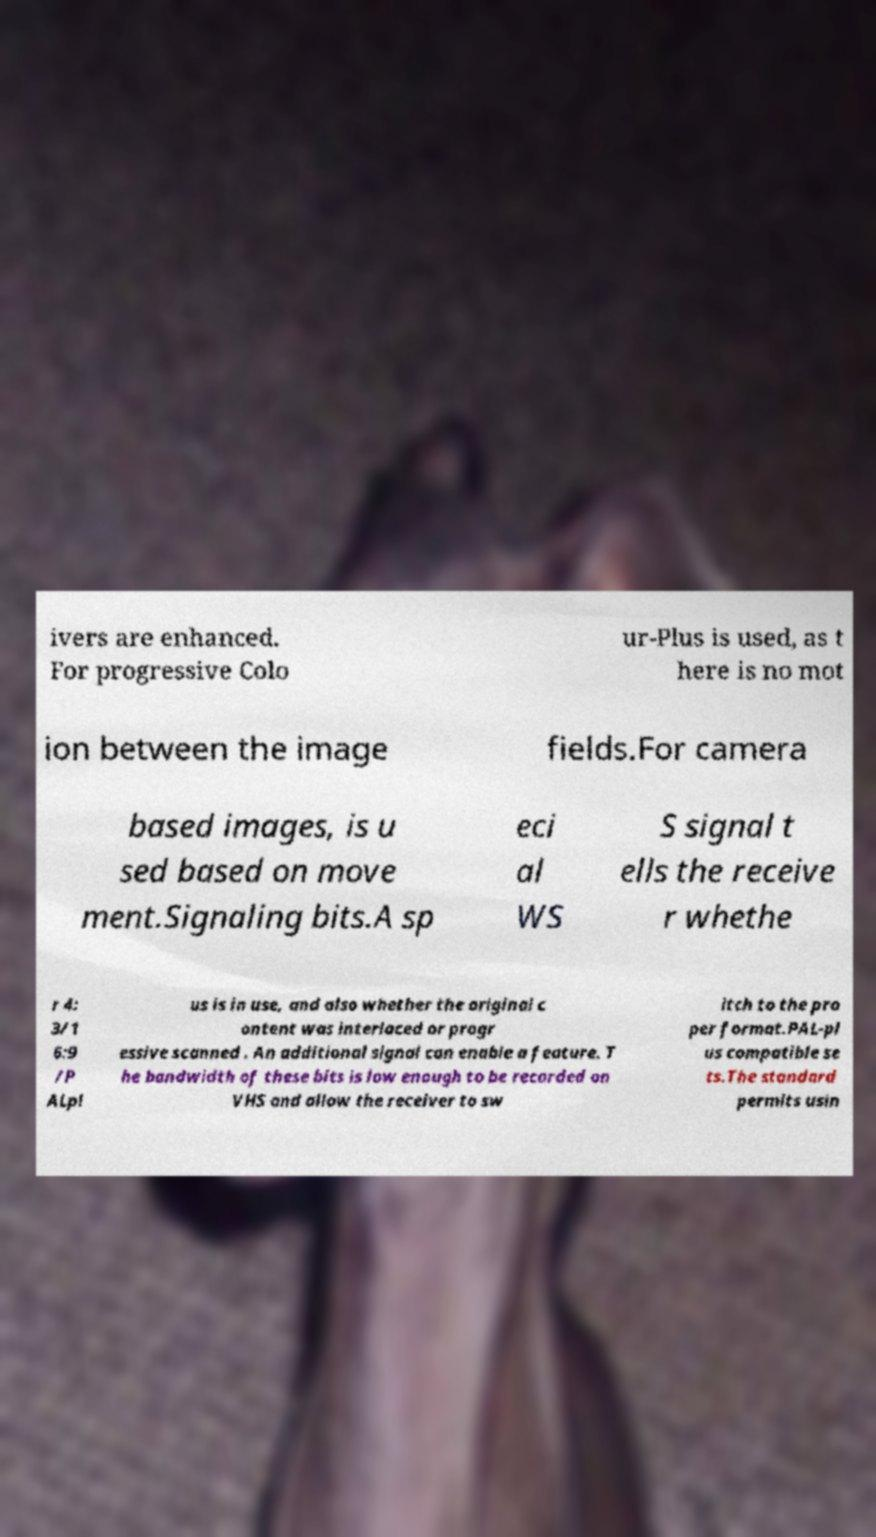Please read and relay the text visible in this image. What does it say? ivers are enhanced. For progressive Colo ur-Plus is used, as t here is no mot ion between the image fields.For camera based images, is u sed based on move ment.Signaling bits.A sp eci al WS S signal t ells the receive r whethe r 4: 3/1 6:9 /P ALpl us is in use, and also whether the original c ontent was interlaced or progr essive scanned . An additional signal can enable a feature. T he bandwidth of these bits is low enough to be recorded on VHS and allow the receiver to sw itch to the pro per format.PAL-pl us compatible se ts.The standard permits usin 